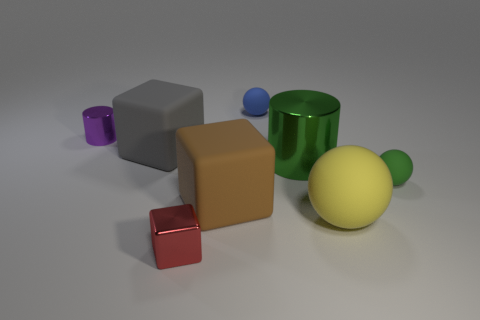Subtract all large balls. How many balls are left? 2 Add 1 tiny brown objects. How many objects exist? 9 Subtract all green cylinders. How many cylinders are left? 1 Subtract all cylinders. How many objects are left? 6 Add 3 big green things. How many big green things are left? 4 Add 1 gray matte things. How many gray matte things exist? 2 Subtract 0 cyan cylinders. How many objects are left? 8 Subtract all brown spheres. Subtract all purple cylinders. How many spheres are left? 3 Subtract all purple metal cylinders. Subtract all large gray rubber things. How many objects are left? 6 